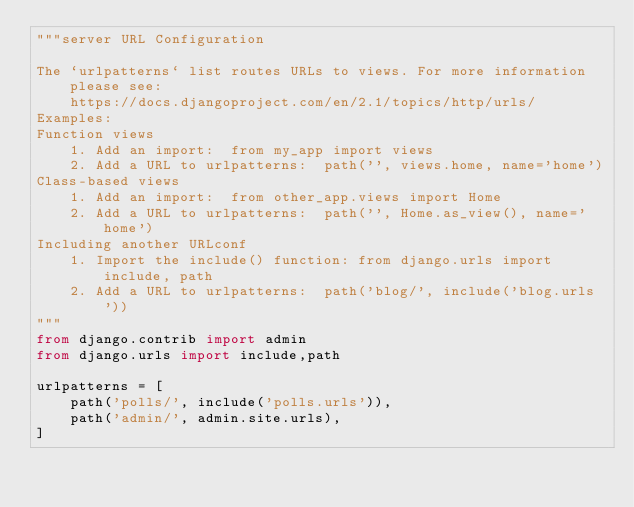Convert code to text. <code><loc_0><loc_0><loc_500><loc_500><_Python_>"""server URL Configuration

The `urlpatterns` list routes URLs to views. For more information please see:
    https://docs.djangoproject.com/en/2.1/topics/http/urls/
Examples:
Function views
    1. Add an import:  from my_app import views
    2. Add a URL to urlpatterns:  path('', views.home, name='home')
Class-based views
    1. Add an import:  from other_app.views import Home
    2. Add a URL to urlpatterns:  path('', Home.as_view(), name='home')
Including another URLconf
    1. Import the include() function: from django.urls import include, path
    2. Add a URL to urlpatterns:  path('blog/', include('blog.urls'))
"""
from django.contrib import admin
from django.urls import include,path

urlpatterns = [
    path('polls/', include('polls.urls')),
    path('admin/', admin.site.urls),
]</code> 